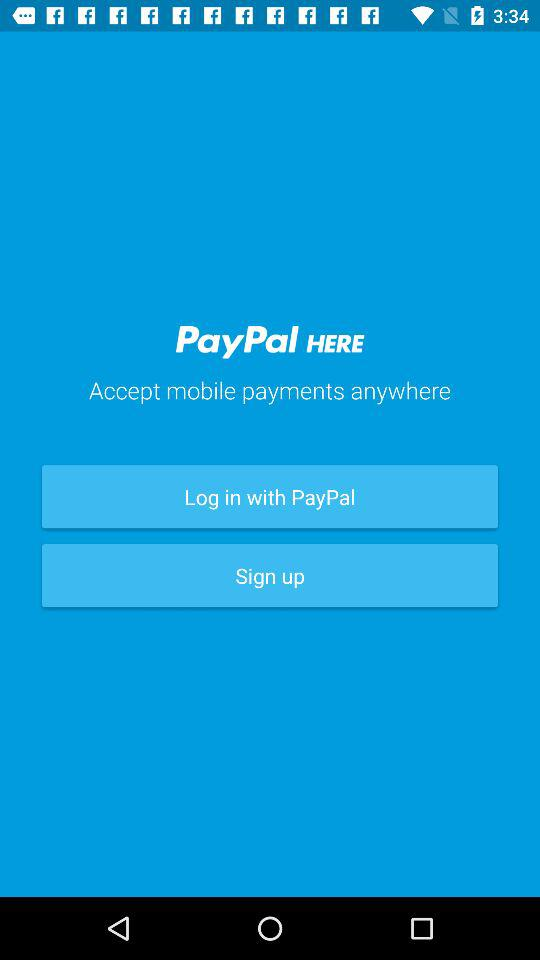If the height of the text 'PayPal HERE' is 329px, and the height of the text 'Accept mobile payments anywhere' is 163px, what is the difference in height between the two texts?
Answer the question using a single word or phrase. 166 